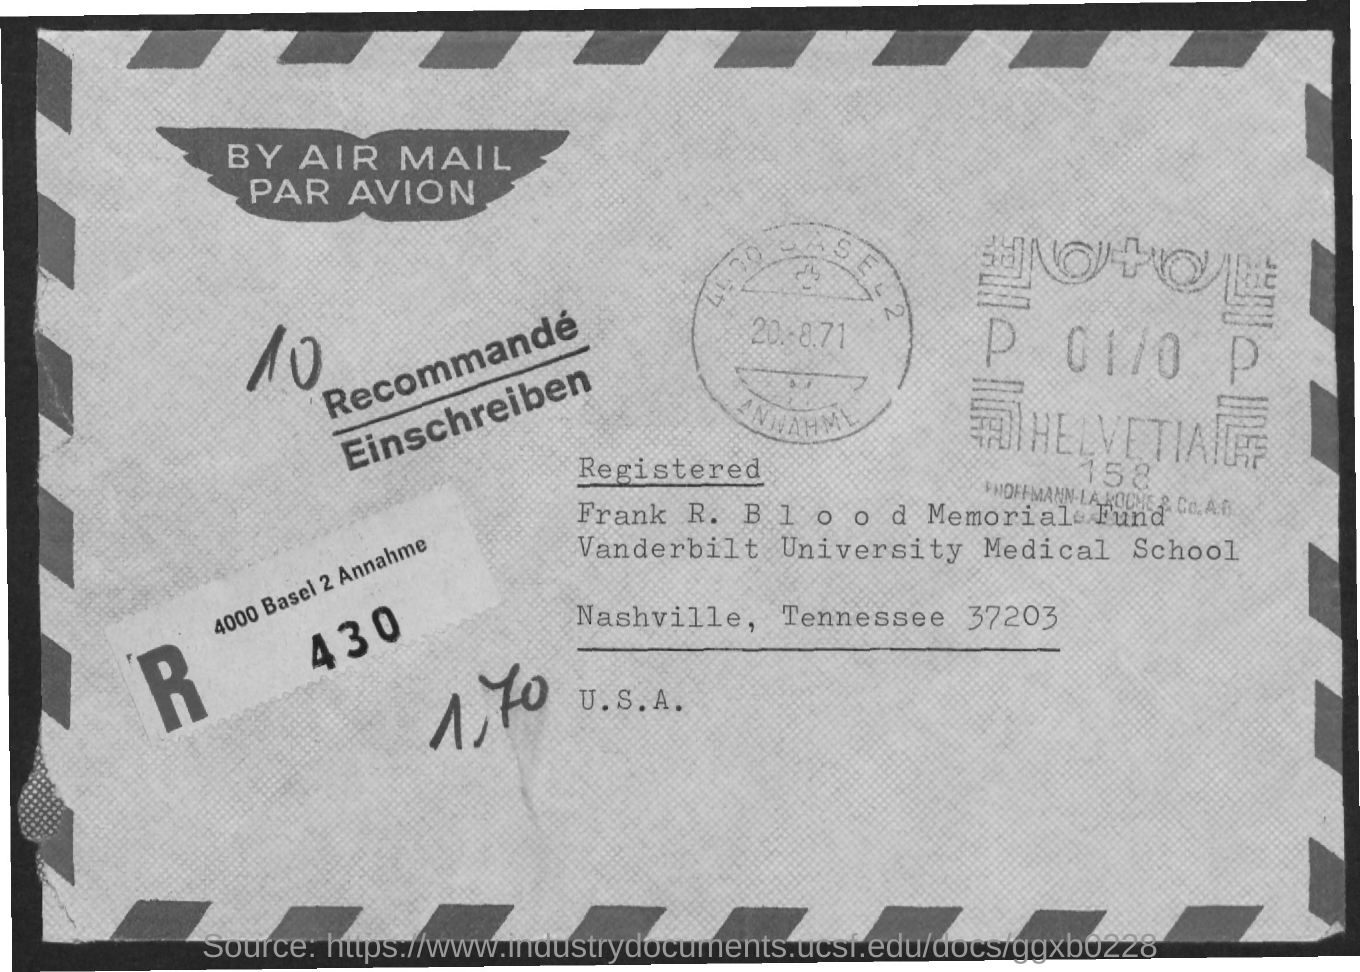Highlight a few significant elements in this photo. Vanderbilt University Medical School is named as "what is the name of the university mentioned ? 